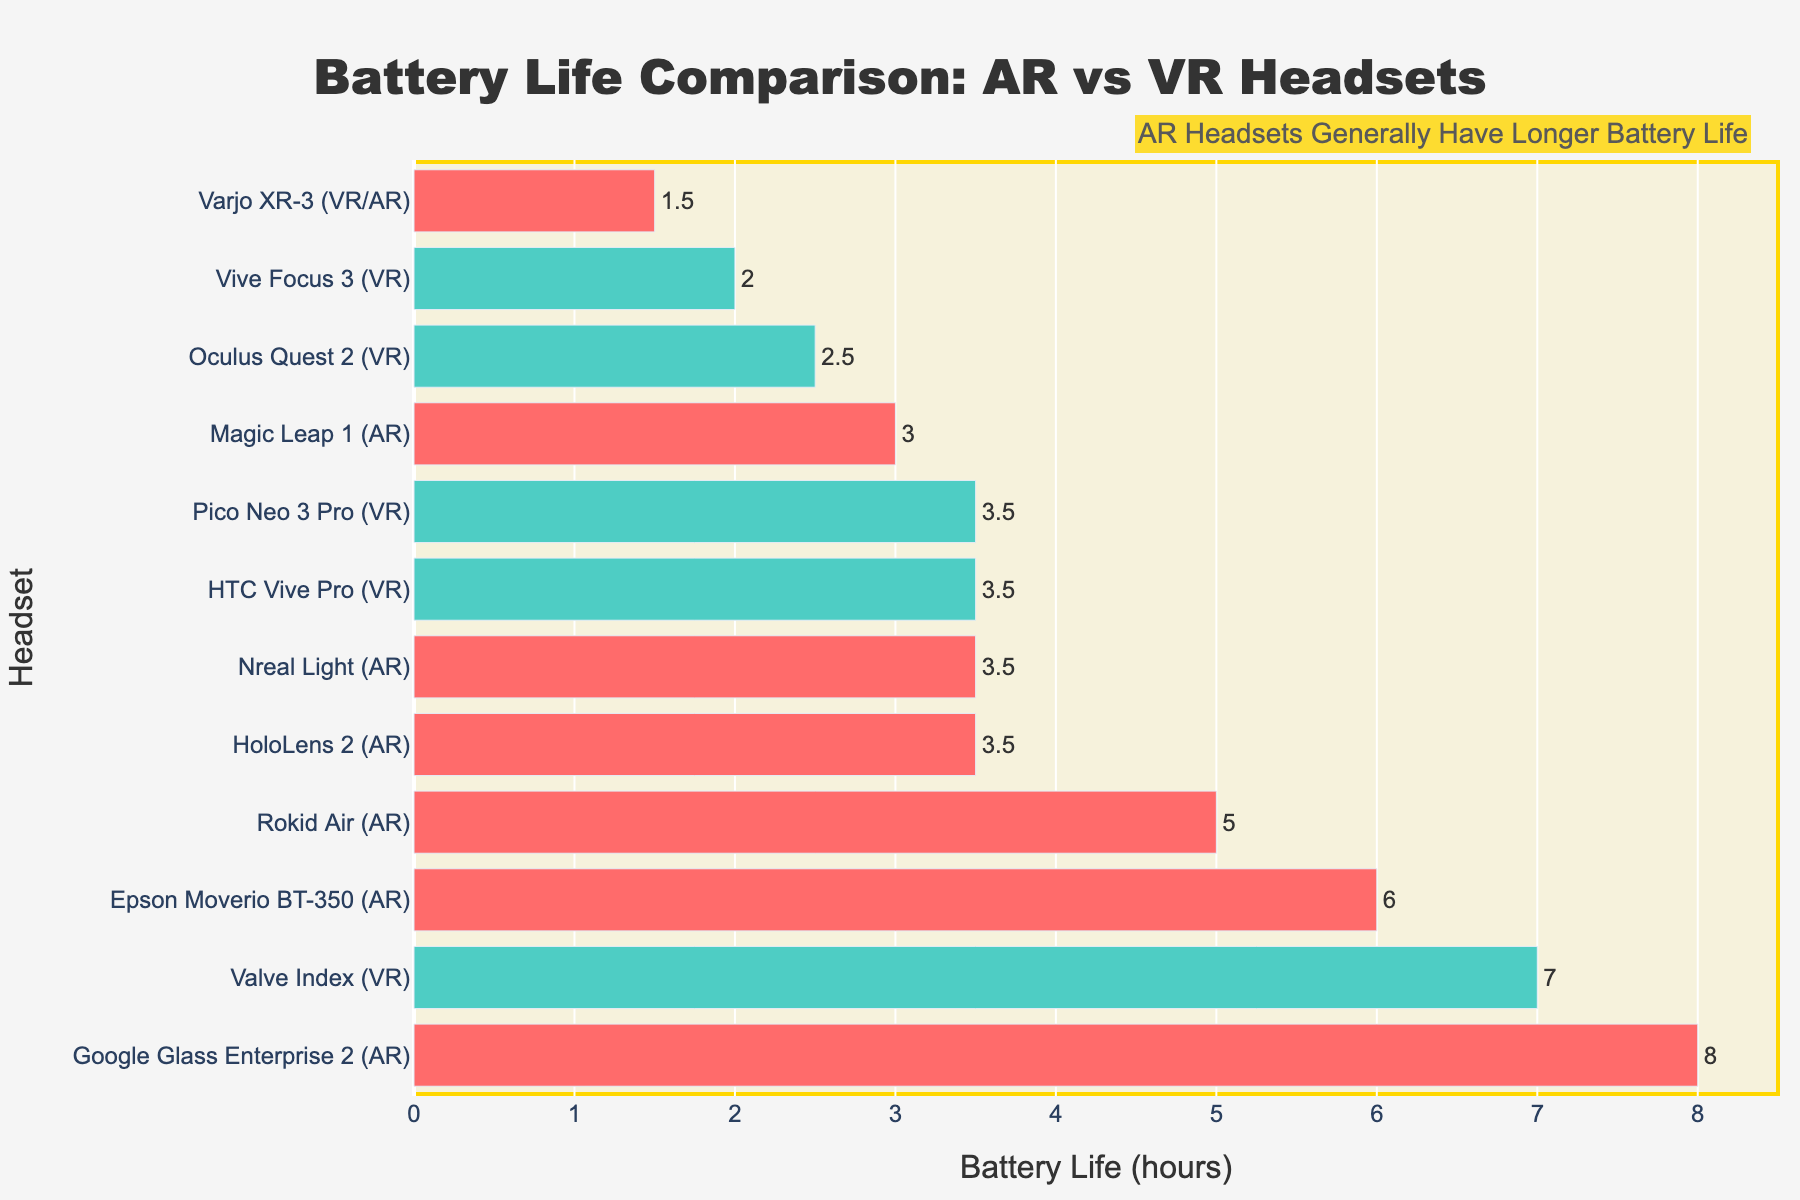what's the difference in battery life between the headset with the longest battery life and the headset with the shortest battery life? The headset with the longest battery life is "Google Glass Enterprise 2 (AR)" with 8 hours, and the one with the shortest battery life is "Varjo XR-3 (VR/AR)" with 1.5 hours. The difference is calculated by subtracting 1.5 from 8.
Answer: 6.5 which AR headset has the shortest battery life, and how does it compare to the shortest in VR? The AR headset with the shortest battery life is "Magic Leap 1" and "Nreal Light," both at 3 hours. The VR headset with the shortest battery life is "Vive Focus 3" at 2 hours.
Answer: AR: 3 hours, VR: 2 hours what is the average battery life of all AR headsets combined? AR headsets are: HoloLens 2 (3.5), Magic Leap 1 (3), Nreal Light (3.5), Google Glass Enterprise 2 (8), Epson Moverio BT-350 (6), and Rokid Air (5). To find the average, sum these values (3.5 + 3 + 3.5 + 8 + 6 + 5) and divide by the number of headsets (6). The sum is 29, and the average is 29/6.
Answer: 4.83 which VR headset has the longest battery life, and what is its value? The VR headset with the longest battery life is "Valve Index" with 7 hours.
Answer: Valve Index, 7 hours how many headsets have a battery life of exactly 3.5 hours, and list their categories? The headsets with a battery life of exactly 3.5 hours are "HoloLens 2 (AR)," "Nreal Light (AR)," "HTC Vive Pro (VR)," and "Pico Neo 3 Pro (VR)"—two AR and two VR.
Answer: 4 headsets: 2 AR, 2 VR what's the total sum of battery life for all VR headsets? VR headsets are: Oculus Quest 2 (2.5), Vive Focus 3 (2), HTC Vive Pro (3.5), Valve Index (7), Pico Neo 3 Pro (3.5). To find the sum, add these values (2.5 + 2 + 3.5 + 7 + 3.5).
Answer: 18.5 hours compare the battery life of "HoloLens 2 (AR)" and "Oculus Quest 2 (VR)." HoloLens 2 has a battery life of 3.5 hours, while Oculus Quest 2 has 2.5 hours. Therefore, HoloLens 2 has 1 hour more battery life than Oculus Quest 2.
Answer: 1 hour more 